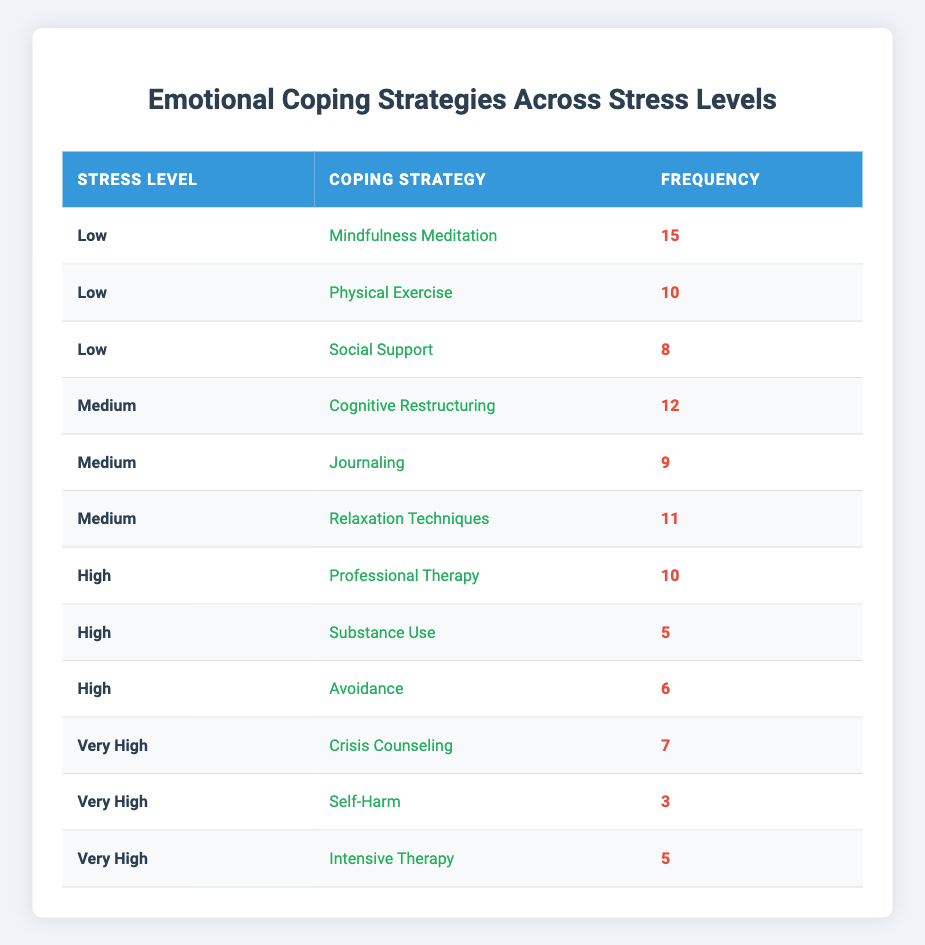What coping strategy had the highest frequency for low stress levels? In the low stress level category, the coping strategies listed are Mindfulness Meditation (15), Physical Exercise (10), and Social Support (8). Among these, Mindfulness Meditation has the highest frequency of 15.
Answer: Mindfulness Meditation What is the total frequency of coping strategies used for high stress levels? For high stress levels, the coping strategies and their frequencies are Professional Therapy (10), Substance Use (5), and Avoidance (6). Adding these together gives 10 + 5 + 6 = 21.
Answer: 21 How many clients used self-harm as a coping strategy at very high stress levels? In the very high stress level category, the frequency of self-harm is listed as 3.
Answer: 3 Is there any coping strategy that was used for both low and medium stress levels? Looking at the table, the coping strategies in low stress are Mindfulness Meditation, Physical Exercise, and Social Support, while in medium stress, they are Cognitive Restructuring, Journaling, and Relaxation Techniques. There are no overlapping strategies between the two groups.
Answer: No What coping strategy is used the least at very high stress levels? In the very high stress level category, the coping strategies with their frequencies are Crisis Counseling (7), Self-Harm (3), and Intensive Therapy (5). The least used strategy here is Self-Harm with a frequency of 3.
Answer: Self-Harm What is the average frequency of coping strategies across all stress levels? The total frequencies are: Low (33), Medium (32), High (21), and Very High (15). Summing these gives 33 + 32 + 21 + 15 = 101. There are 11 strategies total, so the average frequency is 101 / 11 ≈ 9.18.
Answer: Approximately 9.18 Is professional therapy more commonly used than substance use at high stress levels? In high stress levels, Professional Therapy has a frequency of 10, while Substance Use has a frequency of 5. Since 10 is greater than 5, it is indeed more common.
Answer: Yes Which coping strategy had the highest frequency among all stress levels combined? The highest frequencies are Mindfulness Meditation (15) at low stress, followed by the others. Comparing all strategies, Mindfulness Meditation has the highest frequency of 15.
Answer: Mindfulness Meditation 